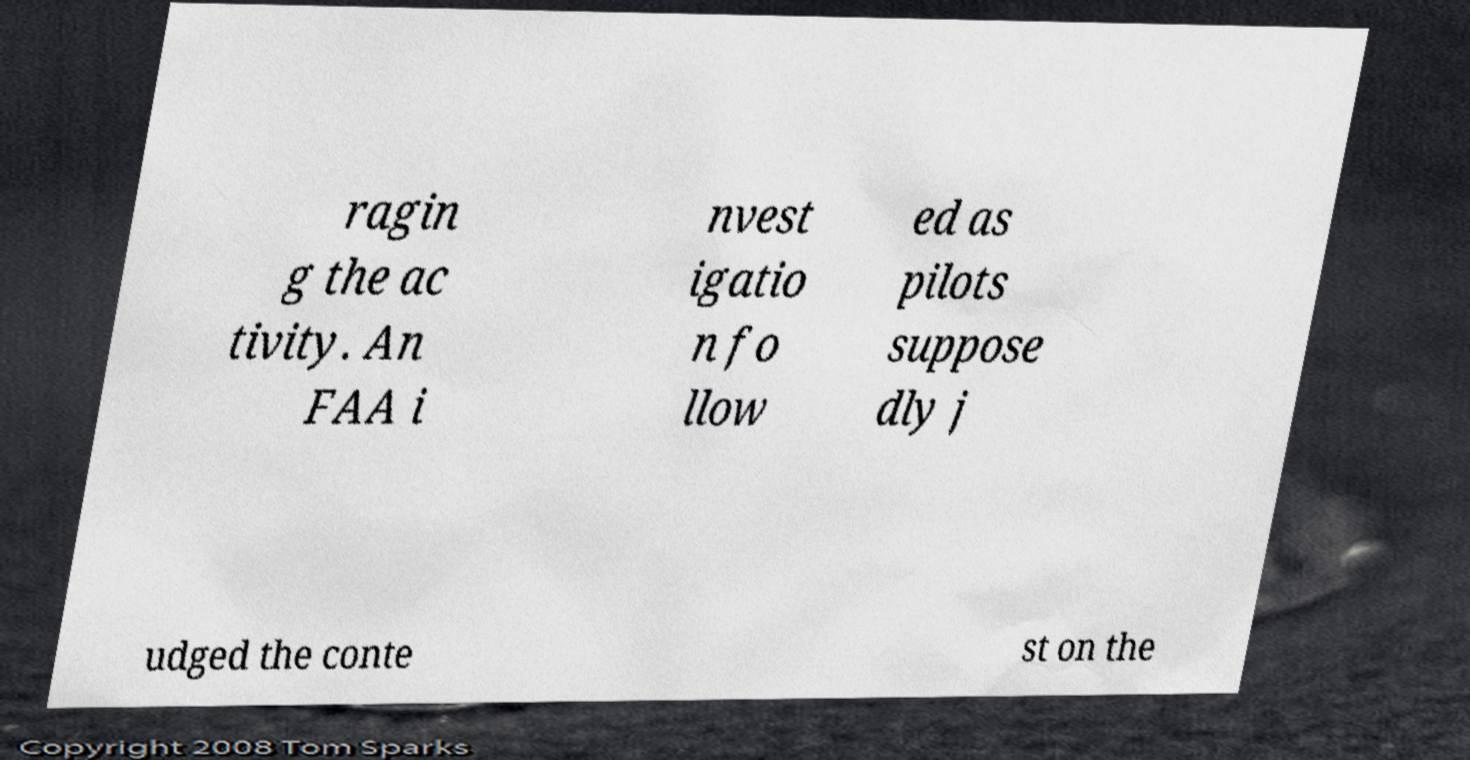There's text embedded in this image that I need extracted. Can you transcribe it verbatim? ragin g the ac tivity. An FAA i nvest igatio n fo llow ed as pilots suppose dly j udged the conte st on the 